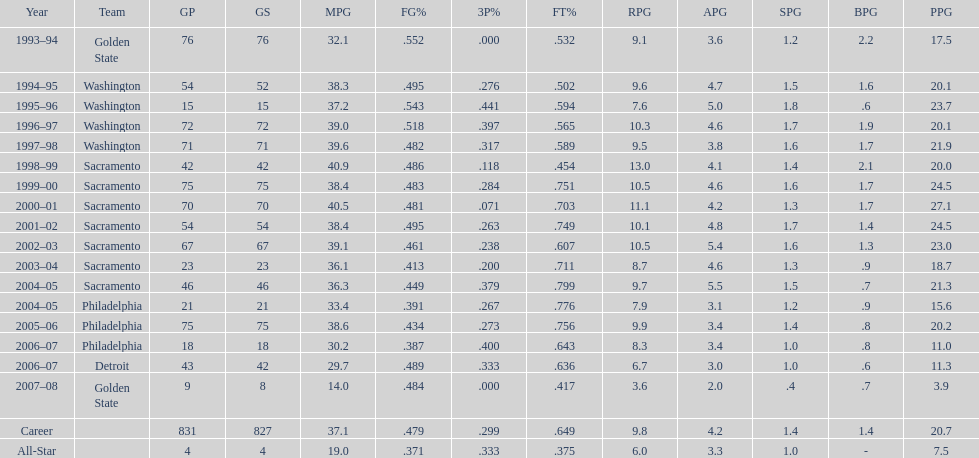How many seasons did webber average over 20 points per game (ppg)? 11. 